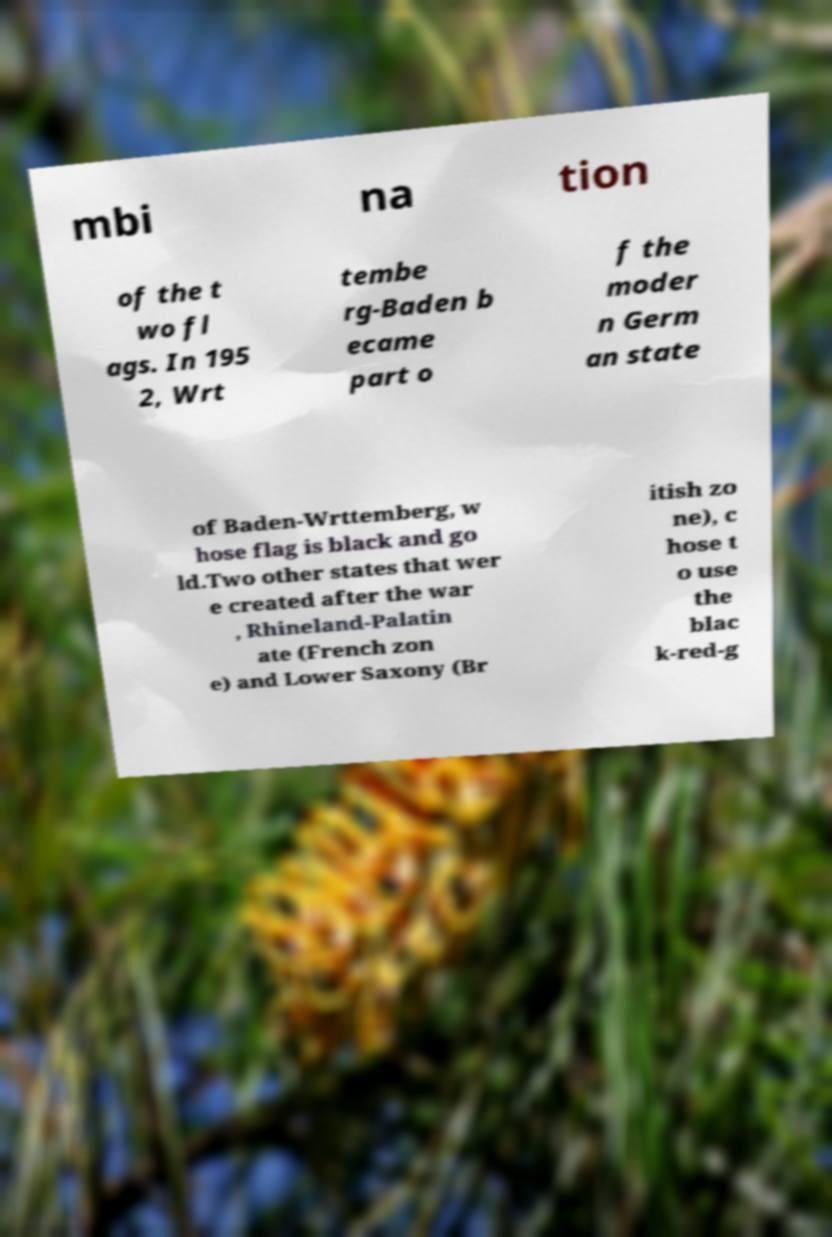Please identify and transcribe the text found in this image. mbi na tion of the t wo fl ags. In 195 2, Wrt tembe rg-Baden b ecame part o f the moder n Germ an state of Baden-Wrttemberg, w hose flag is black and go ld.Two other states that wer e created after the war , Rhineland-Palatin ate (French zon e) and Lower Saxony (Br itish zo ne), c hose t o use the blac k-red-g 